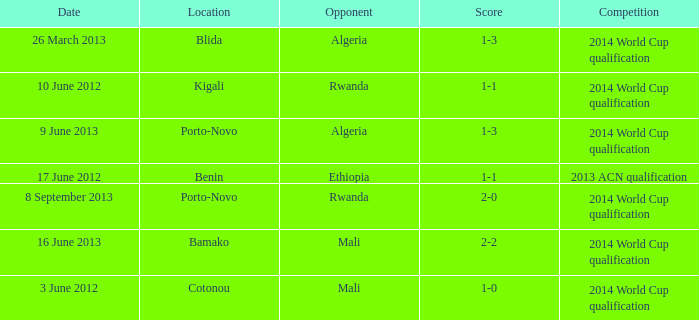What is the result of the match with algeria as the adversary in porto-novo? 1-3. 